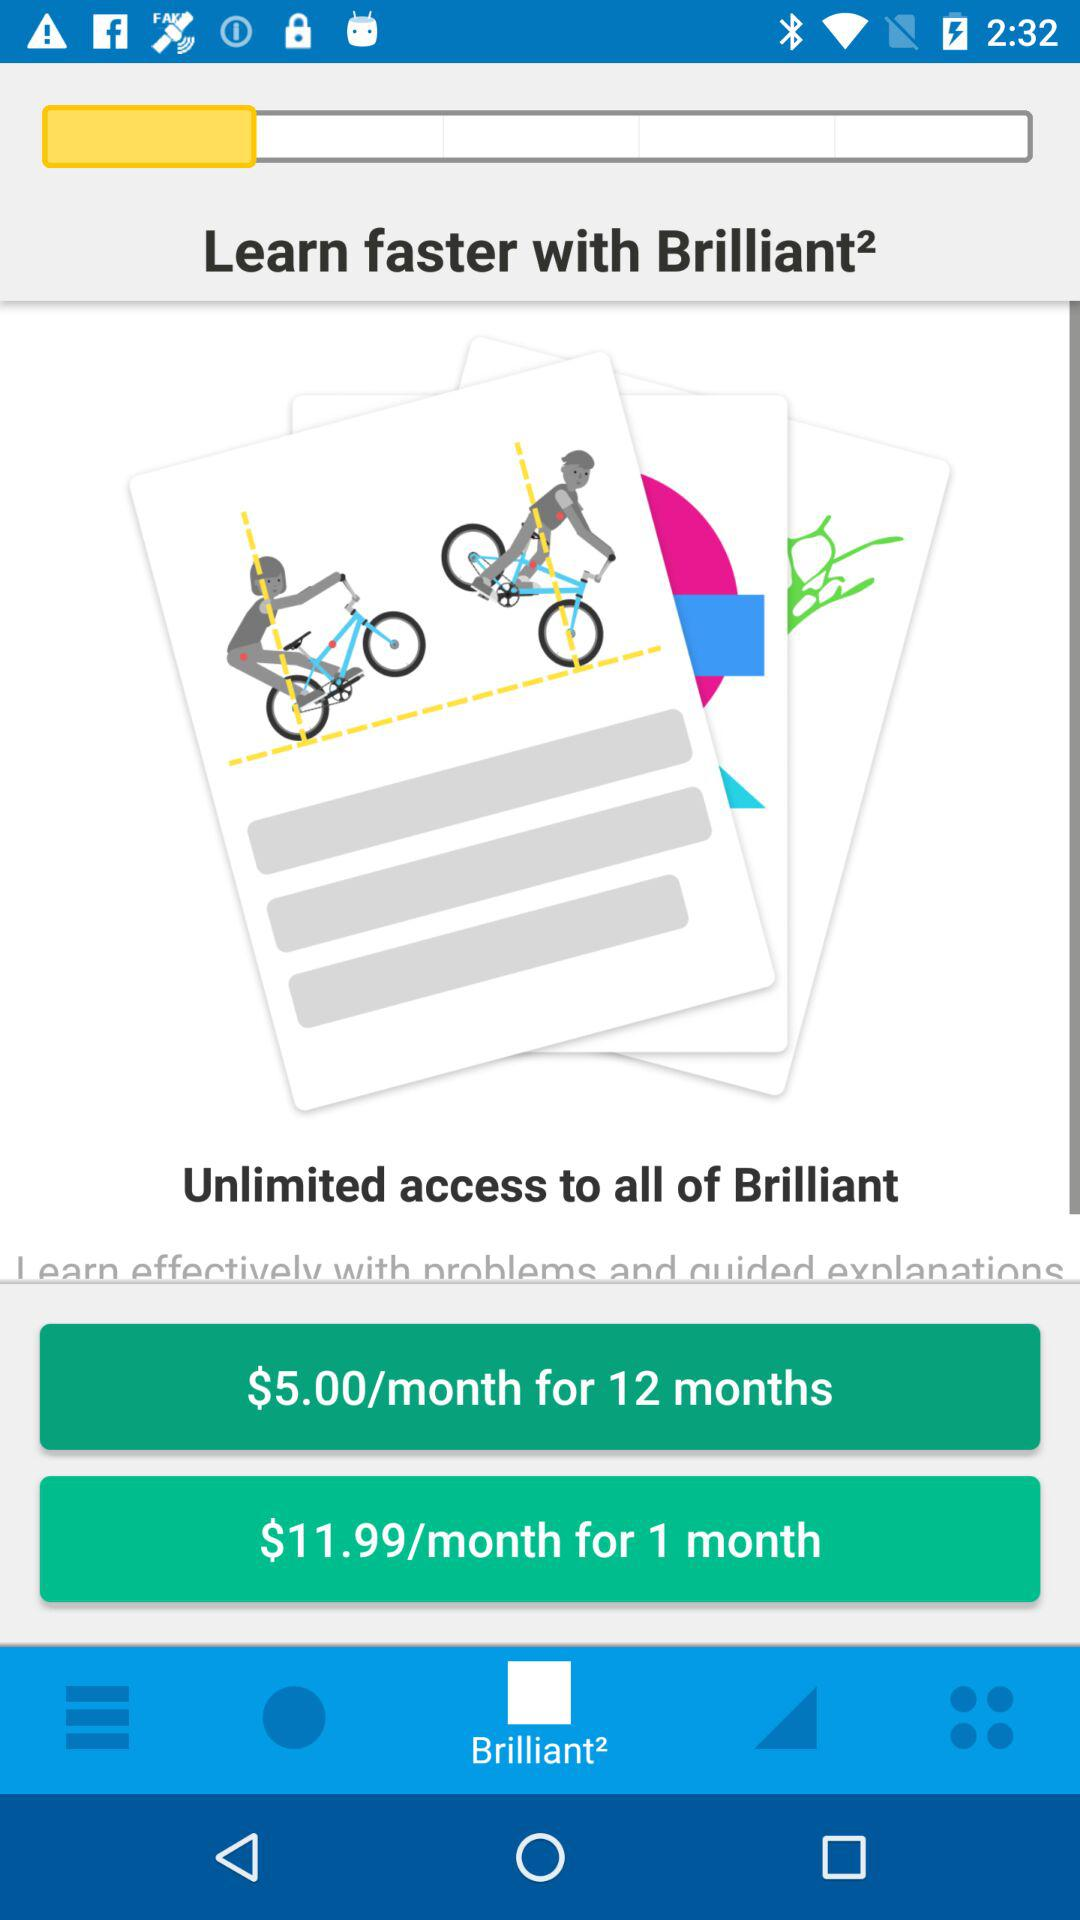Which tab is selected? The selected tab is "Brilliant²". 